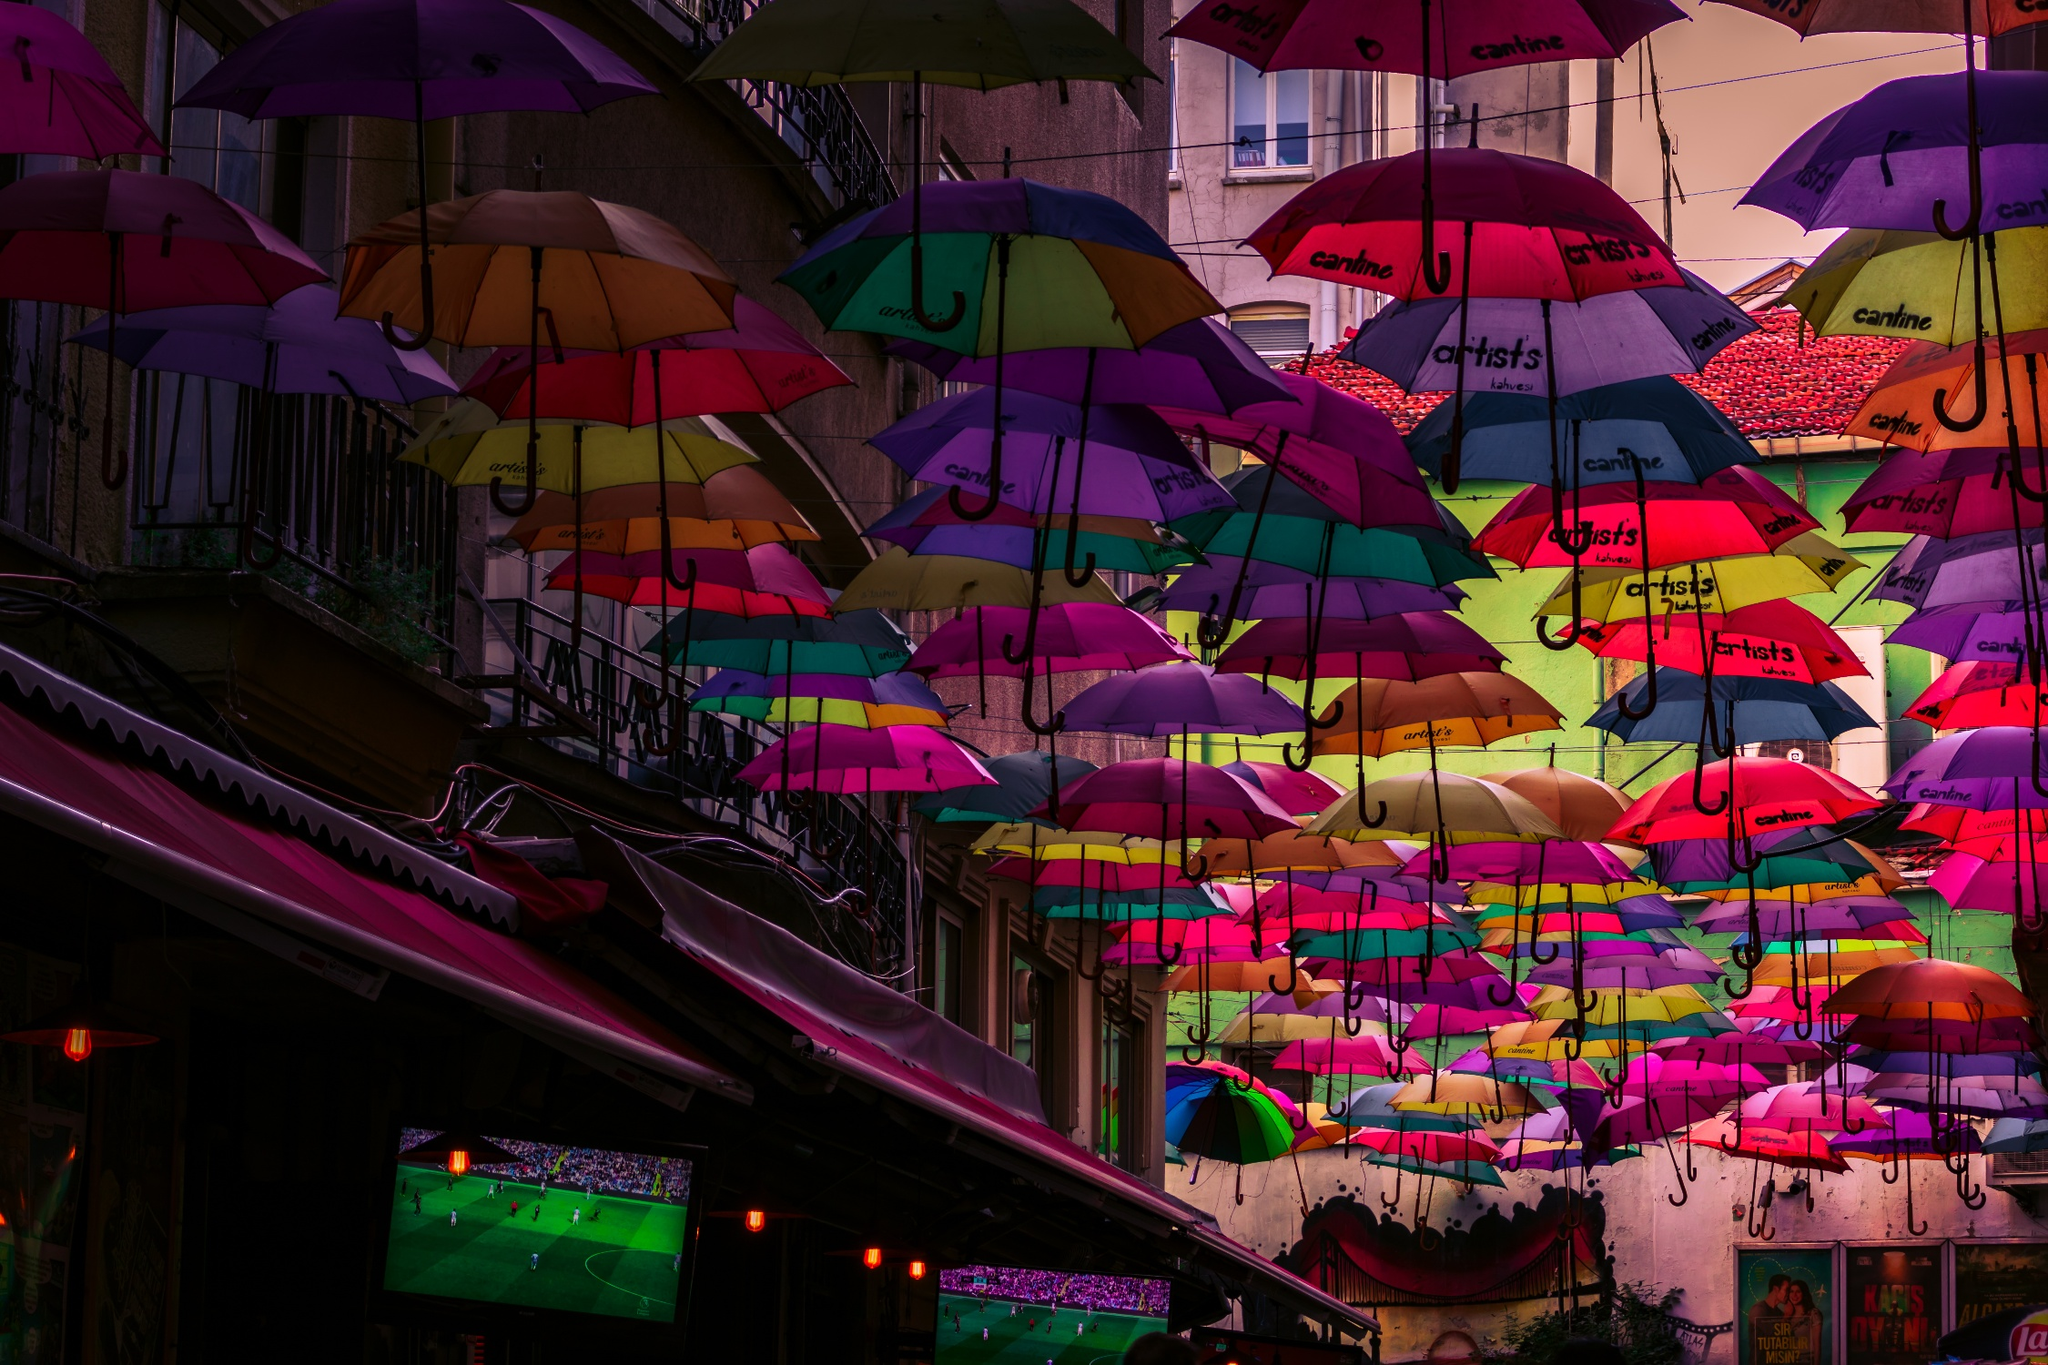Can you explain the cultural significance of using umbrellas in this manner? These suspended umbrellas are often featured in art installations or as part of seasonal festivals, particularly in European countries such as Portugal. They add both aesthetic appeal and practical shelter, transforming ordinary streets into vibrant, immersive environments. This colorful display can draw tourists and locals alike, fostering a sense of community and celebration. Additionally, these installations can serve to promote local businesses and cultural events, as indicated by the branding on some of the umbrellas. Beyond their practical uses, such displays engage people’s imagination and are often associated with fostering local civic pride and artistic expression. 